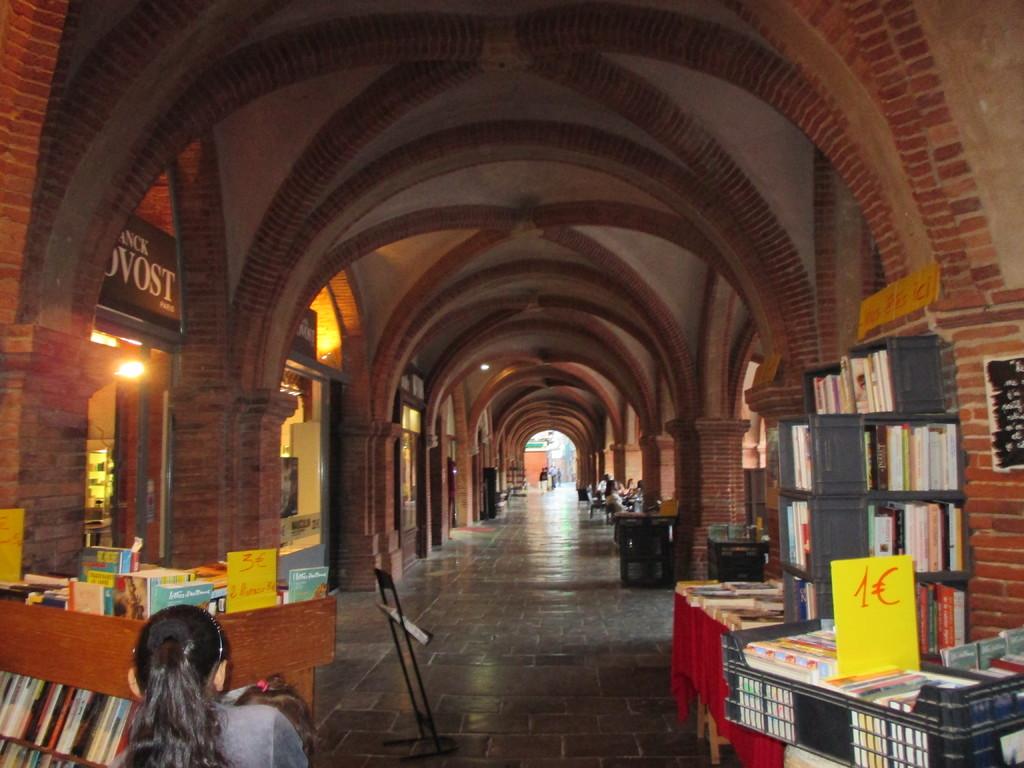What number is on the yellow sign on the right?
Your answer should be compact. 1. Does that sign say "provost"?
Your response must be concise. Yes. 